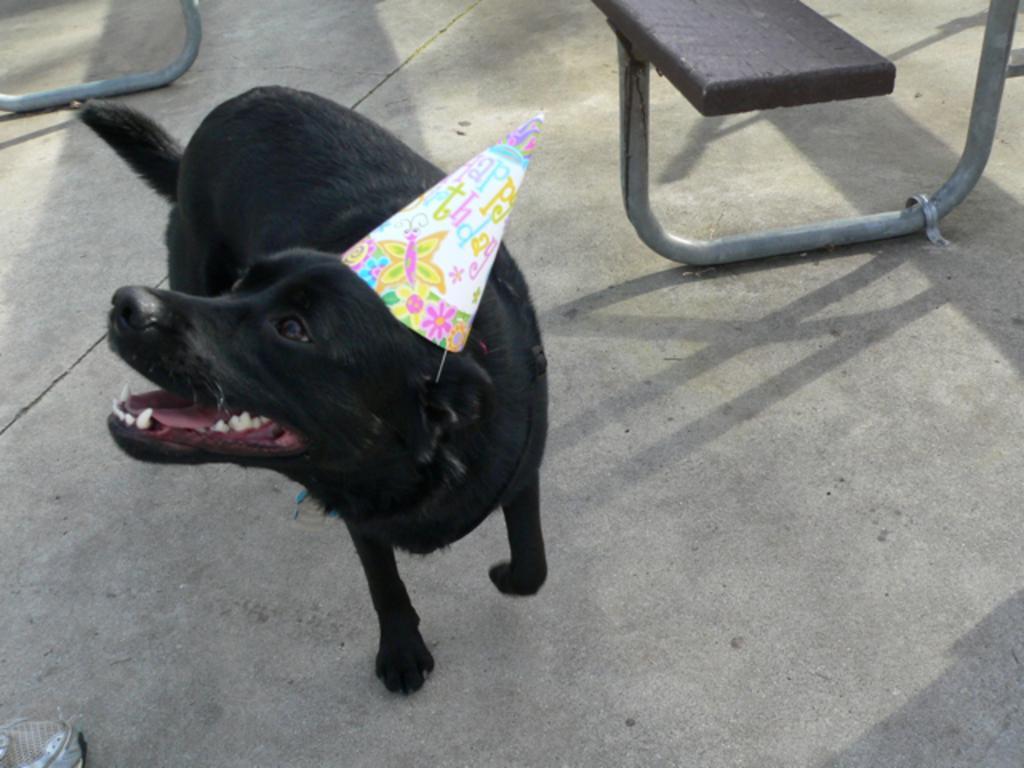Can you describe this image briefly? In this image we can see a dog with a cap on the floor and in the background it looks like a bench. 